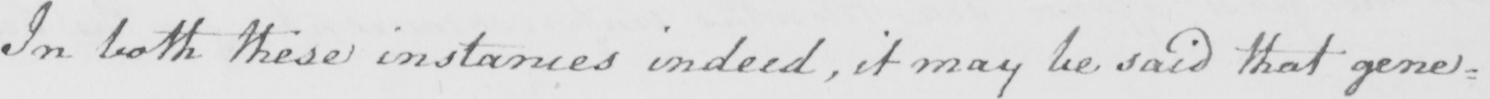Can you tell me what this handwritten text says? In both these instances indeed , it may be said that gener= 